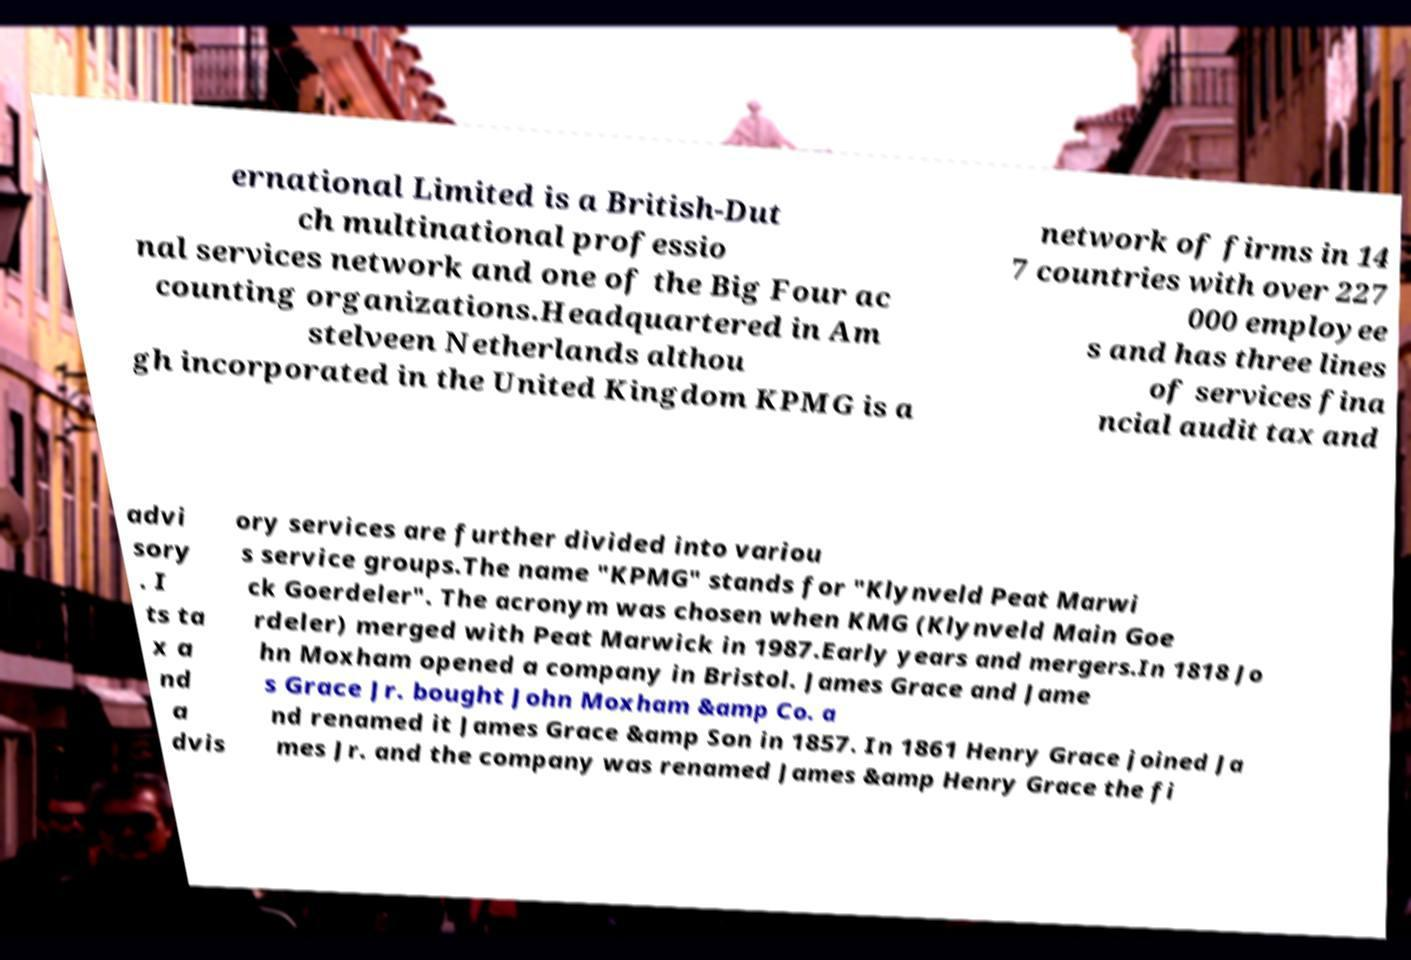Please read and relay the text visible in this image. What does it say? ernational Limited is a British-Dut ch multinational professio nal services network and one of the Big Four ac counting organizations.Headquartered in Am stelveen Netherlands althou gh incorporated in the United Kingdom KPMG is a network of firms in 14 7 countries with over 227 000 employee s and has three lines of services fina ncial audit tax and advi sory . I ts ta x a nd a dvis ory services are further divided into variou s service groups.The name "KPMG" stands for "Klynveld Peat Marwi ck Goerdeler". The acronym was chosen when KMG (Klynveld Main Goe rdeler) merged with Peat Marwick in 1987.Early years and mergers.In 1818 Jo hn Moxham opened a company in Bristol. James Grace and Jame s Grace Jr. bought John Moxham &amp Co. a nd renamed it James Grace &amp Son in 1857. In 1861 Henry Grace joined Ja mes Jr. and the company was renamed James &amp Henry Grace the fi 